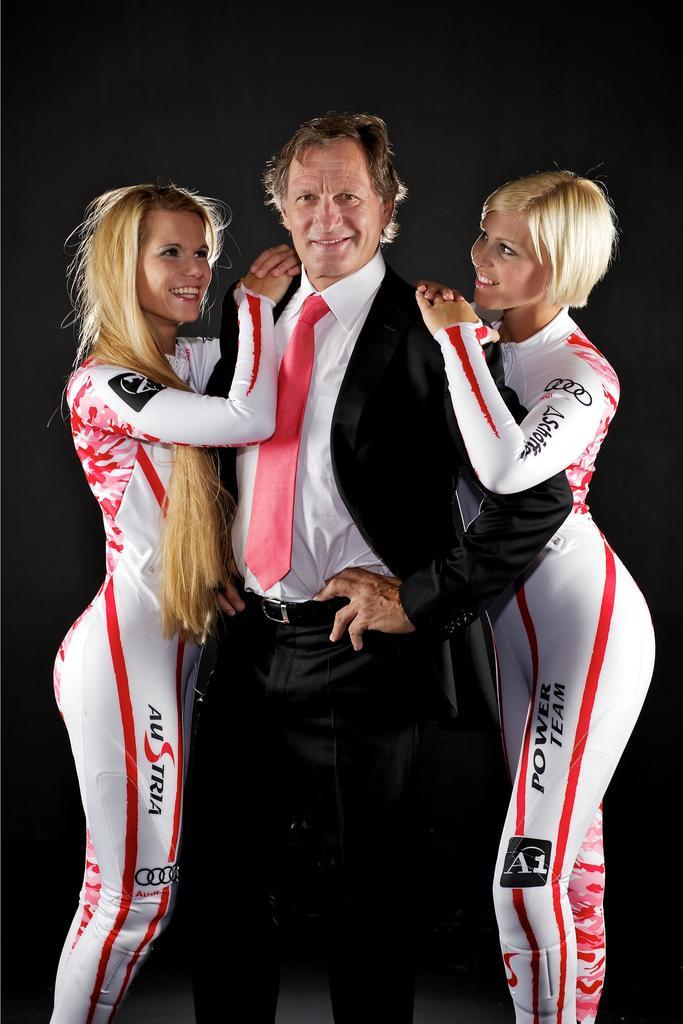<image>
Write a terse but informative summary of the picture. A man in standing in the middle of two blonde females with AUSTRIA and POWER TEAM on the clothing they're wearing. 